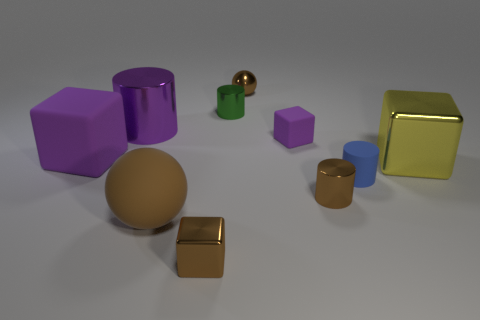Subtract all tiny brown metal cubes. How many cubes are left? 3 Subtract 2 blocks. How many blocks are left? 2 Subtract all brown cubes. How many cubes are left? 3 Subtract all brown blocks. Subtract all blue cylinders. How many blocks are left? 3 Subtract all green cylinders. How many red balls are left? 0 Subtract all small purple cubes. Subtract all gray cylinders. How many objects are left? 9 Add 3 brown metal blocks. How many brown metal blocks are left? 4 Add 3 green metal cylinders. How many green metal cylinders exist? 4 Subtract 0 yellow spheres. How many objects are left? 10 Subtract all balls. How many objects are left? 8 